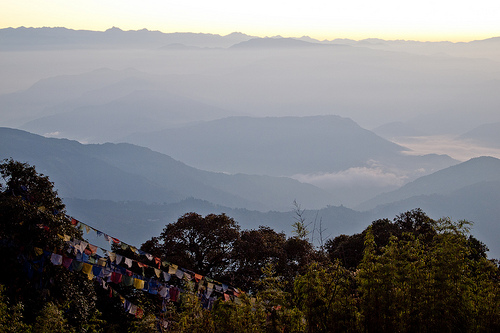<image>
Is the flag on the mountains? No. The flag is not positioned on the mountains. They may be near each other, but the flag is not supported by or resting on top of the mountains. 